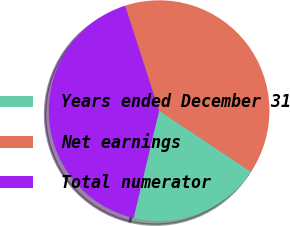Convert chart. <chart><loc_0><loc_0><loc_500><loc_500><pie_chart><fcel>Years ended December 31<fcel>Net earnings<fcel>Total numerator<nl><fcel>19.37%<fcel>39.32%<fcel>41.31%<nl></chart> 